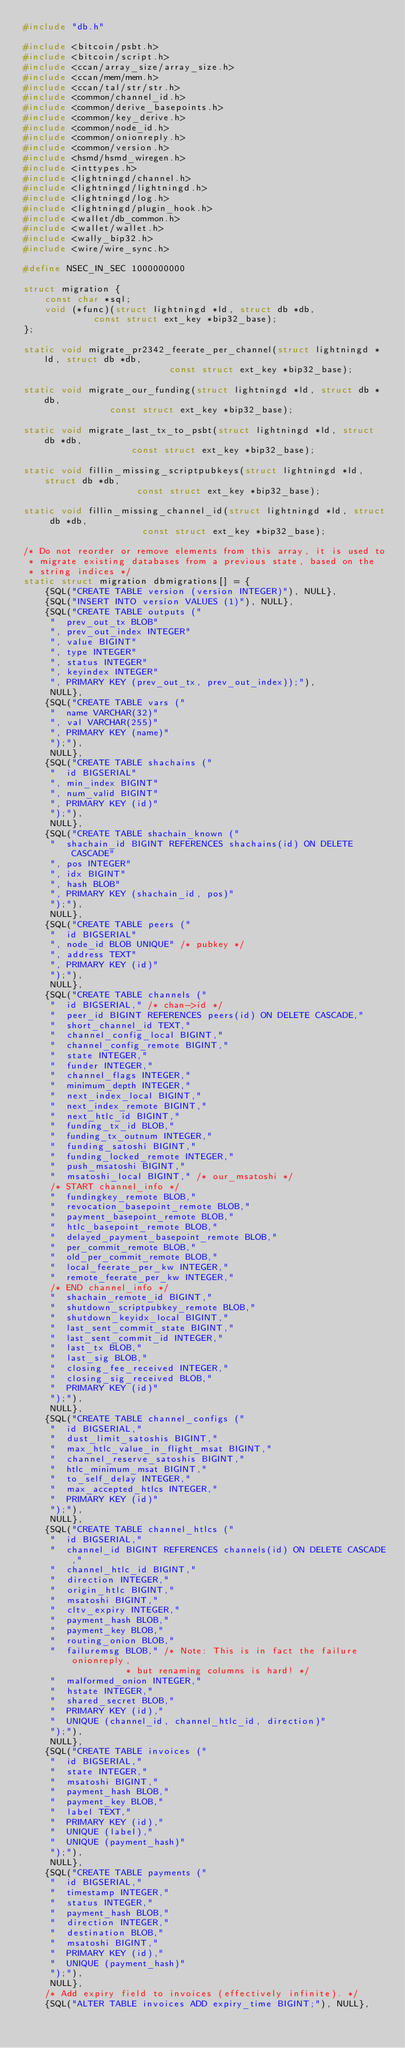Convert code to text. <code><loc_0><loc_0><loc_500><loc_500><_C_>#include "db.h"

#include <bitcoin/psbt.h>
#include <bitcoin/script.h>
#include <ccan/array_size/array_size.h>
#include <ccan/mem/mem.h>
#include <ccan/tal/str/str.h>
#include <common/channel_id.h>
#include <common/derive_basepoints.h>
#include <common/key_derive.h>
#include <common/node_id.h>
#include <common/onionreply.h>
#include <common/version.h>
#include <hsmd/hsmd_wiregen.h>
#include <inttypes.h>
#include <lightningd/channel.h>
#include <lightningd/lightningd.h>
#include <lightningd/log.h>
#include <lightningd/plugin_hook.h>
#include <wallet/db_common.h>
#include <wallet/wallet.h>
#include <wally_bip32.h>
#include <wire/wire_sync.h>

#define NSEC_IN_SEC 1000000000

struct migration {
	const char *sql;
	void (*func)(struct lightningd *ld, struct db *db,
		     const struct ext_key *bip32_base);
};

static void migrate_pr2342_feerate_per_channel(struct lightningd *ld, struct db *db,
					       const struct ext_key *bip32_base);

static void migrate_our_funding(struct lightningd *ld, struct db *db,
				const struct ext_key *bip32_base);

static void migrate_last_tx_to_psbt(struct lightningd *ld, struct db *db,
				    const struct ext_key *bip32_base);

static void fillin_missing_scriptpubkeys(struct lightningd *ld, struct db *db,
					 const struct ext_key *bip32_base);

static void fillin_missing_channel_id(struct lightningd *ld, struct db *db,
				      const struct ext_key *bip32_base);

/* Do not reorder or remove elements from this array, it is used to
 * migrate existing databases from a previous state, based on the
 * string indices */
static struct migration dbmigrations[] = {
    {SQL("CREATE TABLE version (version INTEGER)"), NULL},
    {SQL("INSERT INTO version VALUES (1)"), NULL},
    {SQL("CREATE TABLE outputs ("
	 "  prev_out_tx BLOB"
	 ", prev_out_index INTEGER"
	 ", value BIGINT"
	 ", type INTEGER"
	 ", status INTEGER"
	 ", keyindex INTEGER"
	 ", PRIMARY KEY (prev_out_tx, prev_out_index));"),
     NULL},
    {SQL("CREATE TABLE vars ("
	 "  name VARCHAR(32)"
	 ", val VARCHAR(255)"
	 ", PRIMARY KEY (name)"
	 ");"),
     NULL},
    {SQL("CREATE TABLE shachains ("
	 "  id BIGSERIAL"
	 ", min_index BIGINT"
	 ", num_valid BIGINT"
	 ", PRIMARY KEY (id)"
	 ");"),
     NULL},
    {SQL("CREATE TABLE shachain_known ("
	 "  shachain_id BIGINT REFERENCES shachains(id) ON DELETE CASCADE"
	 ", pos INTEGER"
	 ", idx BIGINT"
	 ", hash BLOB"
	 ", PRIMARY KEY (shachain_id, pos)"
	 ");"),
     NULL},
    {SQL("CREATE TABLE peers ("
	 "  id BIGSERIAL"
	 ", node_id BLOB UNIQUE" /* pubkey */
	 ", address TEXT"
	 ", PRIMARY KEY (id)"
	 ");"),
     NULL},
    {SQL("CREATE TABLE channels ("
	 "  id BIGSERIAL," /* chan->id */
	 "  peer_id BIGINT REFERENCES peers(id) ON DELETE CASCADE,"
	 "  short_channel_id TEXT,"
	 "  channel_config_local BIGINT,"
	 "  channel_config_remote BIGINT,"
	 "  state INTEGER,"
	 "  funder INTEGER,"
	 "  channel_flags INTEGER,"
	 "  minimum_depth INTEGER,"
	 "  next_index_local BIGINT,"
	 "  next_index_remote BIGINT,"
	 "  next_htlc_id BIGINT,"
	 "  funding_tx_id BLOB,"
	 "  funding_tx_outnum INTEGER,"
	 "  funding_satoshi BIGINT,"
	 "  funding_locked_remote INTEGER,"
	 "  push_msatoshi BIGINT,"
	 "  msatoshi_local BIGINT," /* our_msatoshi */
	 /* START channel_info */
	 "  fundingkey_remote BLOB,"
	 "  revocation_basepoint_remote BLOB,"
	 "  payment_basepoint_remote BLOB,"
	 "  htlc_basepoint_remote BLOB,"
	 "  delayed_payment_basepoint_remote BLOB,"
	 "  per_commit_remote BLOB,"
	 "  old_per_commit_remote BLOB,"
	 "  local_feerate_per_kw INTEGER,"
	 "  remote_feerate_per_kw INTEGER,"
	 /* END channel_info */
	 "  shachain_remote_id BIGINT,"
	 "  shutdown_scriptpubkey_remote BLOB,"
	 "  shutdown_keyidx_local BIGINT,"
	 "  last_sent_commit_state BIGINT,"
	 "  last_sent_commit_id INTEGER,"
	 "  last_tx BLOB,"
	 "  last_sig BLOB,"
	 "  closing_fee_received INTEGER,"
	 "  closing_sig_received BLOB,"
	 "  PRIMARY KEY (id)"
	 ");"),
     NULL},
    {SQL("CREATE TABLE channel_configs ("
	 "  id BIGSERIAL,"
	 "  dust_limit_satoshis BIGINT,"
	 "  max_htlc_value_in_flight_msat BIGINT,"
	 "  channel_reserve_satoshis BIGINT,"
	 "  htlc_minimum_msat BIGINT,"
	 "  to_self_delay INTEGER,"
	 "  max_accepted_htlcs INTEGER,"
	 "  PRIMARY KEY (id)"
	 ");"),
     NULL},
    {SQL("CREATE TABLE channel_htlcs ("
	 "  id BIGSERIAL,"
	 "  channel_id BIGINT REFERENCES channels(id) ON DELETE CASCADE,"
	 "  channel_htlc_id BIGINT,"
	 "  direction INTEGER,"
	 "  origin_htlc BIGINT,"
	 "  msatoshi BIGINT,"
	 "  cltv_expiry INTEGER,"
	 "  payment_hash BLOB,"
	 "  payment_key BLOB,"
	 "  routing_onion BLOB,"
	 "  failuremsg BLOB," /* Note: This is in fact the failure onionreply,
			       * but renaming columns is hard! */
	 "  malformed_onion INTEGER,"
	 "  hstate INTEGER,"
	 "  shared_secret BLOB,"
	 "  PRIMARY KEY (id),"
	 "  UNIQUE (channel_id, channel_htlc_id, direction)"
	 ");"),
     NULL},
    {SQL("CREATE TABLE invoices ("
	 "  id BIGSERIAL,"
	 "  state INTEGER,"
	 "  msatoshi BIGINT,"
	 "  payment_hash BLOB,"
	 "  payment_key BLOB,"
	 "  label TEXT,"
	 "  PRIMARY KEY (id),"
	 "  UNIQUE (label),"
	 "  UNIQUE (payment_hash)"
	 ");"),
     NULL},
    {SQL("CREATE TABLE payments ("
	 "  id BIGSERIAL,"
	 "  timestamp INTEGER,"
	 "  status INTEGER,"
	 "  payment_hash BLOB,"
	 "  direction INTEGER,"
	 "  destination BLOB,"
	 "  msatoshi BIGINT,"
	 "  PRIMARY KEY (id),"
	 "  UNIQUE (payment_hash)"
	 ");"),
     NULL},
    /* Add expiry field to invoices (effectively infinite). */
    {SQL("ALTER TABLE invoices ADD expiry_time BIGINT;"), NULL},</code> 